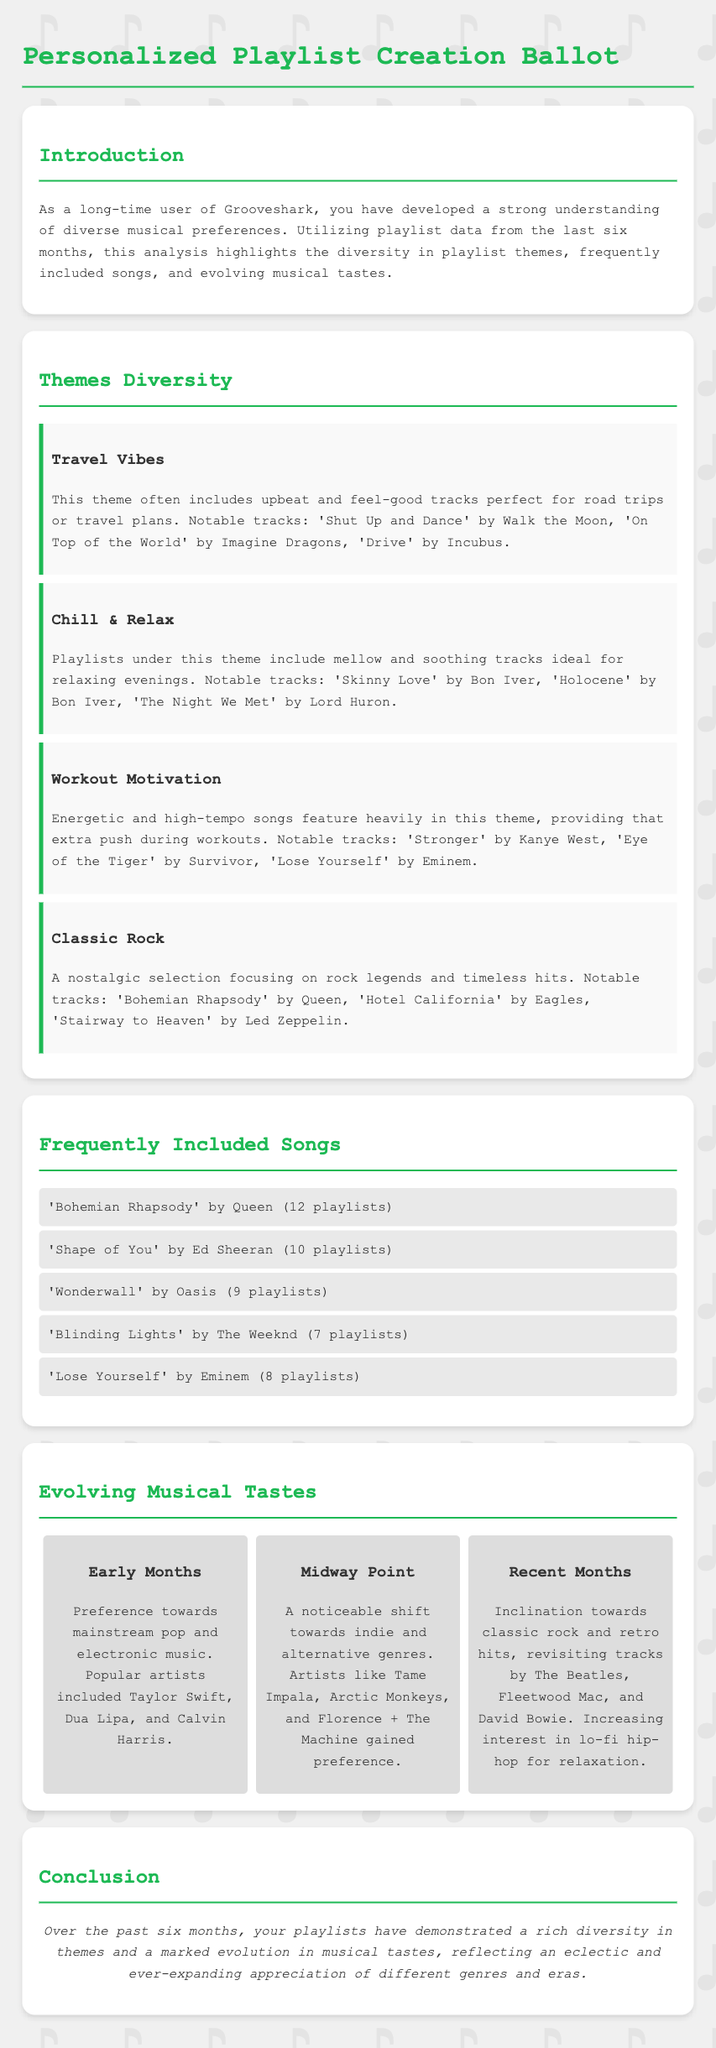What is the primary theme for road trips? The document highlights a theme called "Travel Vibes" which includes upbeat tracks suitable for road trips.
Answer: Travel Vibes Which song appears in the most playlists? The song 'Bohemian Rhapsody' by Queen is mentioned as appearing in 12 playlists.
Answer: 'Bohemian Rhapsody' by Queen What genre of music gained preference midway through the last six months? The document states a noticeable shift towards indie and alternative genres occurred midway through the timeline.
Answer: Indie and alternative How many playlists include 'Blinding Lights' by The Weeknd? The document specifically states that 'Blinding Lights' by The Weeknd is included in 7 playlists.
Answer: 7 playlists What type of songs are featured in the "Workout Motivation" theme? The "Workout Motivation" theme is characterized by energetic and high-tempo songs providing motivation during workouts.
Answer: Energetic and high-tempo songs Which artists were popular during the early months? The document lists Taylor Swift, Dua Lipa, and Calvin Harris as popular artists in the early months.
Answer: Taylor Swift, Dua Lipa, and Calvin Harris How many themes are discussed in the document? The document discusses four themes in total related to playlist creation.
Answer: Four themes What does the conclusion mention about musical tastes? The conclusion reflects a rich diversity in themes and an evolution in musical tastes over the past six months.
Answer: Rich diversity in themes and evolution in musical tastes What song is associated with nostalgia in the "Classic Rock" theme? 'Bohemian Rhapsody' by Queen is highlighted as a nostalgic selection in the "Classic Rock" theme.
Answer: 'Bohemian Rhapsody' by Queen 